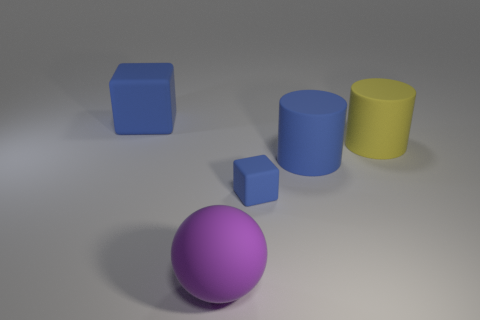The rubber block that is the same size as the purple matte object is what color?
Offer a very short reply. Blue. How many blue rubber objects are the same shape as the yellow thing?
Your response must be concise. 1. Does the blue cube that is in front of the large matte block have the same material as the big cube?
Keep it short and to the point. Yes. How many cylinders are either big cyan matte things or purple rubber objects?
Provide a short and direct response. 0. The big thing in front of the blue matte object that is in front of the large rubber cylinder on the left side of the yellow cylinder is what shape?
Offer a very short reply. Sphere. There is a tiny rubber thing that is the same color as the large rubber cube; what is its shape?
Keep it short and to the point. Cube. How many matte things have the same size as the blue cylinder?
Make the answer very short. 3. There is a block in front of the big blue block; is there a small blue object behind it?
Give a very brief answer. No. How many things are either large brown matte cylinders or balls?
Your answer should be very brief. 1. There is a large ball in front of the block that is on the left side of the large rubber thing that is in front of the small block; what color is it?
Your response must be concise. Purple. 